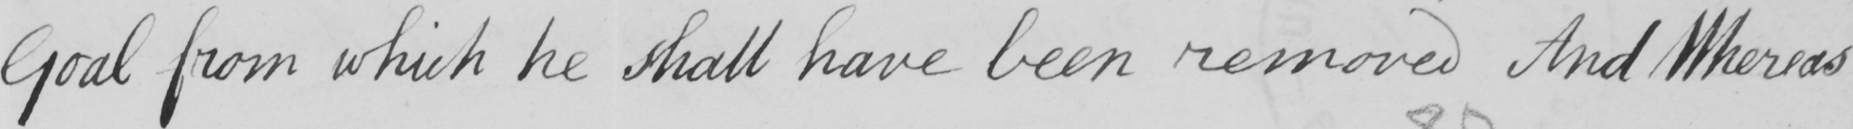Please transcribe the handwritten text in this image. Goal from which he shall have been removed And Whereas 